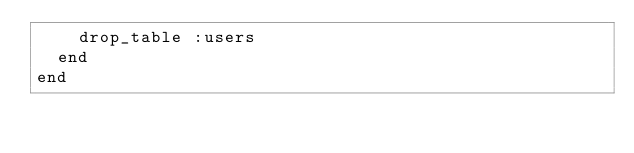Convert code to text. <code><loc_0><loc_0><loc_500><loc_500><_Ruby_>    drop_table :users
  end
end
</code> 